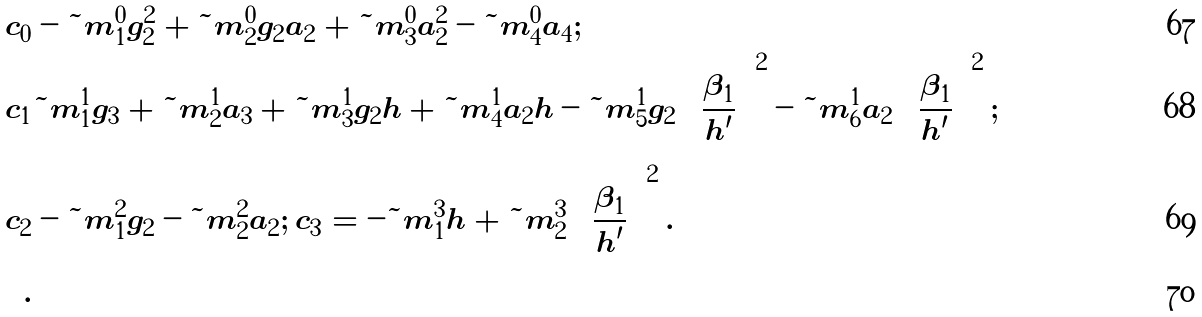<formula> <loc_0><loc_0><loc_500><loc_500>c _ { 0 } & - { \tilde { m } } ^ { 0 } _ { 1 } g _ { 2 } ^ { 2 } + { \tilde { m } } ^ { 0 } _ { 2 } g _ { 2 } a _ { 2 } + { \tilde { m } } ^ { 0 } _ { 3 } a _ { 2 } ^ { 2 } - { \tilde { m } } ^ { 0 } _ { 4 } a _ { 4 } ; \\ c _ { 1 } & { \tilde { m } } ^ { 1 } _ { 1 } g _ { 3 } + { \tilde { m } } ^ { 1 } _ { 2 } a _ { 3 } + { \tilde { m } } ^ { 1 } _ { 3 } g _ { 2 } h + { \tilde { m } } ^ { 1 } _ { 4 } a _ { 2 } h - { \tilde { m } } ^ { 1 } _ { 5 } g _ { 2 } \left ( \frac { \beta _ { 1 } } { h ^ { \prime } } \right ) ^ { 2 } - { \tilde { m } } ^ { 1 } _ { 6 } a _ { 2 } \left ( \frac { \beta _ { 1 } } { h ^ { \prime } } \right ) ^ { 2 } ; \\ c _ { 2 } & - { \tilde { m } } ^ { 2 } _ { 1 } g _ { 2 } - { \tilde { m } } ^ { 2 } _ { 2 } a _ { 2 } ; \, c _ { 3 } = - { \tilde { m } } ^ { 3 } _ { 1 } h + { \tilde { m } } ^ { 3 } _ { 2 } \left ( \frac { \beta _ { 1 } } { h ^ { \prime } } \right ) ^ { 2 } . \\ .</formula> 